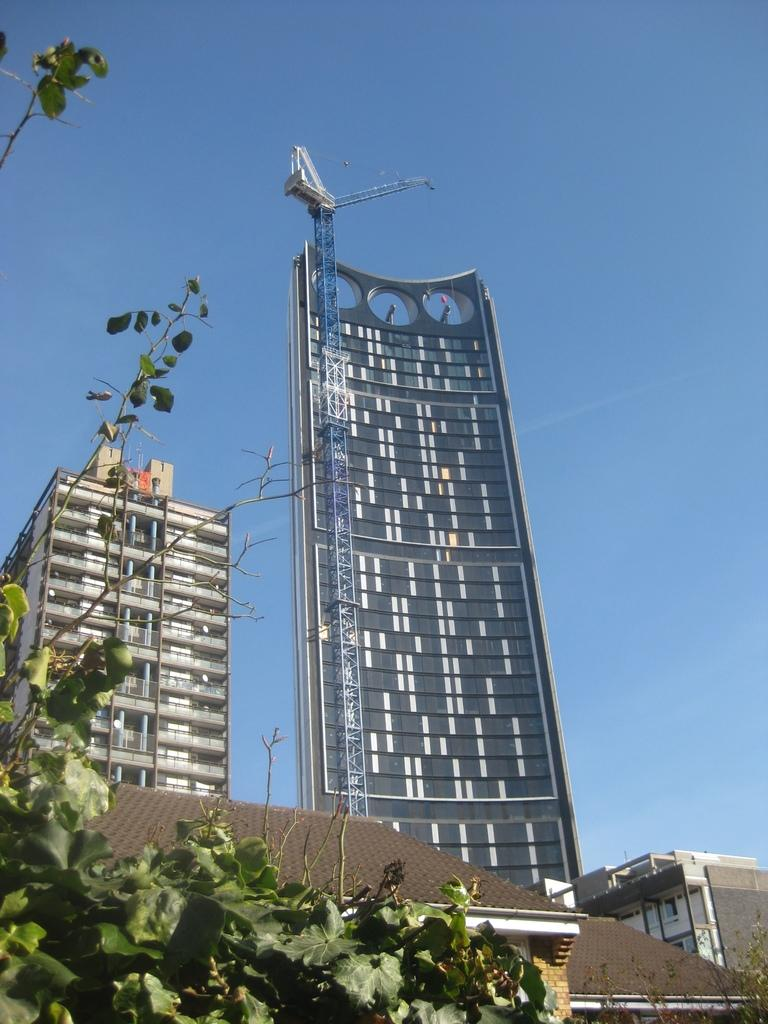What type of structures can be seen in the image? There are buildings and a tower in the image. What else can be found in the image besides structures? There are plants in the image. What part of the natural environment is visible in the image? The sky is visible in the image. What invention is being demonstrated in the image? There is no invention being demonstrated in the image; it features buildings, a tower, plants, and the sky. What religious symbol can be seen in the image? There is no religious symbol present in the image. 